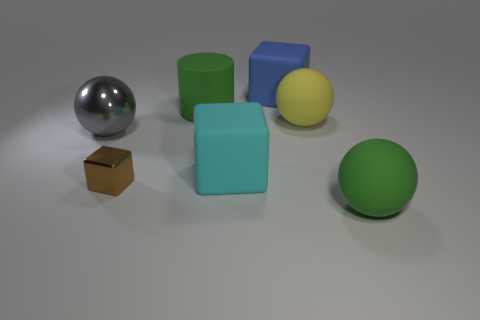Is there anything else that has the same size as the brown metal thing?
Provide a short and direct response. No. What number of other things are the same size as the yellow matte thing?
Ensure brevity in your answer.  5. What color is the sphere left of the big rubber thing behind the large green rubber object that is left of the yellow sphere?
Your response must be concise. Gray. What is the shape of the object that is both in front of the cyan object and right of the small metallic cube?
Provide a short and direct response. Sphere. What number of other things are there of the same shape as the large metal thing?
Your answer should be compact. 2. There is a big green matte thing behind the large object left of the metal thing that is right of the gray thing; what is its shape?
Provide a succinct answer. Cylinder. How many objects are either yellow blocks or things that are on the right side of the big cyan object?
Your answer should be very brief. 3. Do the metal object right of the gray metal ball and the big matte object behind the green matte cylinder have the same shape?
Your response must be concise. Yes. What number of things are cyan matte cubes or gray metallic things?
Provide a succinct answer. 2. Are any tiny red objects visible?
Give a very brief answer. No. 